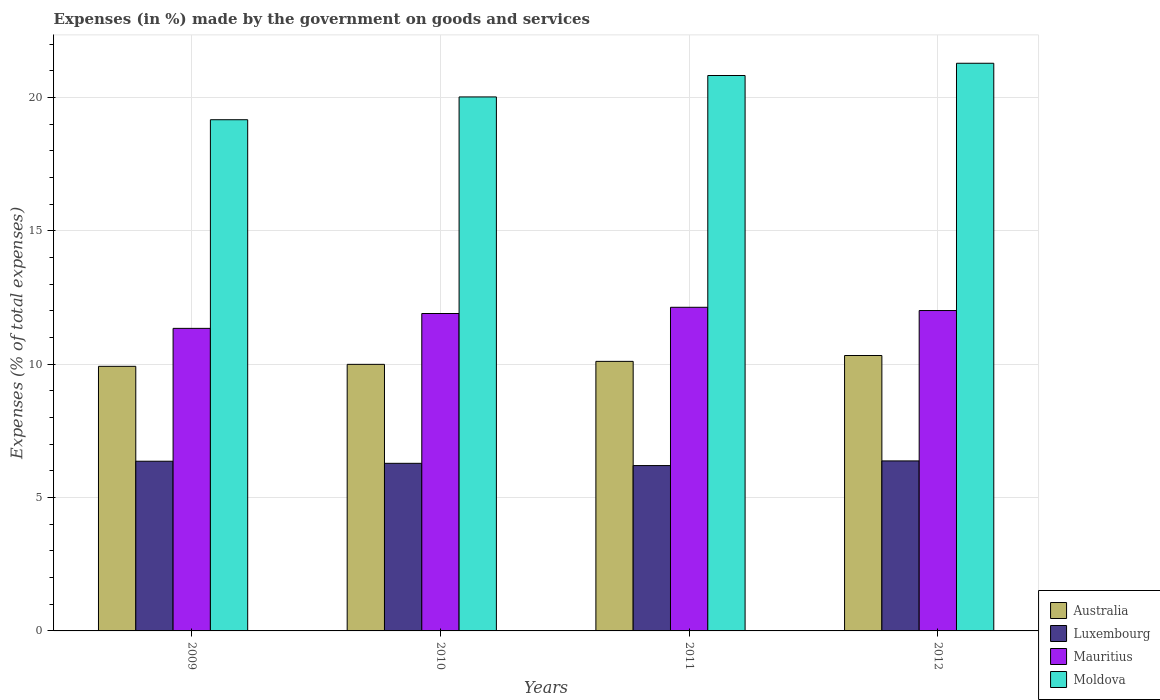How many different coloured bars are there?
Keep it short and to the point. 4. Are the number of bars on each tick of the X-axis equal?
Offer a very short reply. Yes. How many bars are there on the 3rd tick from the right?
Your answer should be compact. 4. What is the percentage of expenses made by the government on goods and services in Australia in 2009?
Your response must be concise. 9.92. Across all years, what is the maximum percentage of expenses made by the government on goods and services in Moldova?
Provide a short and direct response. 21.28. Across all years, what is the minimum percentage of expenses made by the government on goods and services in Australia?
Provide a succinct answer. 9.92. What is the total percentage of expenses made by the government on goods and services in Mauritius in the graph?
Give a very brief answer. 47.38. What is the difference between the percentage of expenses made by the government on goods and services in Australia in 2010 and that in 2011?
Offer a terse response. -0.11. What is the difference between the percentage of expenses made by the government on goods and services in Luxembourg in 2011 and the percentage of expenses made by the government on goods and services in Australia in 2012?
Offer a very short reply. -4.13. What is the average percentage of expenses made by the government on goods and services in Moldova per year?
Give a very brief answer. 20.32. In the year 2011, what is the difference between the percentage of expenses made by the government on goods and services in Moldova and percentage of expenses made by the government on goods and services in Luxembourg?
Ensure brevity in your answer.  14.62. What is the ratio of the percentage of expenses made by the government on goods and services in Mauritius in 2010 to that in 2012?
Offer a very short reply. 0.99. Is the percentage of expenses made by the government on goods and services in Moldova in 2010 less than that in 2011?
Your answer should be very brief. Yes. What is the difference between the highest and the second highest percentage of expenses made by the government on goods and services in Mauritius?
Provide a short and direct response. 0.12. What is the difference between the highest and the lowest percentage of expenses made by the government on goods and services in Moldova?
Ensure brevity in your answer.  2.12. In how many years, is the percentage of expenses made by the government on goods and services in Mauritius greater than the average percentage of expenses made by the government on goods and services in Mauritius taken over all years?
Ensure brevity in your answer.  3. Is the sum of the percentage of expenses made by the government on goods and services in Luxembourg in 2011 and 2012 greater than the maximum percentage of expenses made by the government on goods and services in Mauritius across all years?
Provide a succinct answer. Yes. Is it the case that in every year, the sum of the percentage of expenses made by the government on goods and services in Mauritius and percentage of expenses made by the government on goods and services in Moldova is greater than the sum of percentage of expenses made by the government on goods and services in Luxembourg and percentage of expenses made by the government on goods and services in Australia?
Keep it short and to the point. Yes. Is it the case that in every year, the sum of the percentage of expenses made by the government on goods and services in Mauritius and percentage of expenses made by the government on goods and services in Moldova is greater than the percentage of expenses made by the government on goods and services in Luxembourg?
Your response must be concise. Yes. How many bars are there?
Offer a terse response. 16. Are all the bars in the graph horizontal?
Ensure brevity in your answer.  No. How many years are there in the graph?
Provide a succinct answer. 4. What is the difference between two consecutive major ticks on the Y-axis?
Provide a succinct answer. 5. Where does the legend appear in the graph?
Make the answer very short. Bottom right. How many legend labels are there?
Provide a short and direct response. 4. How are the legend labels stacked?
Provide a short and direct response. Vertical. What is the title of the graph?
Offer a terse response. Expenses (in %) made by the government on goods and services. What is the label or title of the X-axis?
Keep it short and to the point. Years. What is the label or title of the Y-axis?
Offer a terse response. Expenses (% of total expenses). What is the Expenses (% of total expenses) of Australia in 2009?
Your answer should be very brief. 9.92. What is the Expenses (% of total expenses) of Luxembourg in 2009?
Provide a short and direct response. 6.36. What is the Expenses (% of total expenses) in Mauritius in 2009?
Your answer should be compact. 11.34. What is the Expenses (% of total expenses) in Moldova in 2009?
Give a very brief answer. 19.16. What is the Expenses (% of total expenses) of Australia in 2010?
Offer a very short reply. 9.99. What is the Expenses (% of total expenses) of Luxembourg in 2010?
Provide a short and direct response. 6.28. What is the Expenses (% of total expenses) of Mauritius in 2010?
Provide a succinct answer. 11.9. What is the Expenses (% of total expenses) in Moldova in 2010?
Your answer should be compact. 20.02. What is the Expenses (% of total expenses) of Australia in 2011?
Provide a short and direct response. 10.11. What is the Expenses (% of total expenses) in Luxembourg in 2011?
Your answer should be compact. 6.2. What is the Expenses (% of total expenses) in Mauritius in 2011?
Provide a short and direct response. 12.13. What is the Expenses (% of total expenses) of Moldova in 2011?
Keep it short and to the point. 20.82. What is the Expenses (% of total expenses) of Australia in 2012?
Offer a terse response. 10.32. What is the Expenses (% of total expenses) of Luxembourg in 2012?
Keep it short and to the point. 6.37. What is the Expenses (% of total expenses) in Mauritius in 2012?
Ensure brevity in your answer.  12.01. What is the Expenses (% of total expenses) in Moldova in 2012?
Make the answer very short. 21.28. Across all years, what is the maximum Expenses (% of total expenses) in Australia?
Your answer should be compact. 10.32. Across all years, what is the maximum Expenses (% of total expenses) in Luxembourg?
Offer a very short reply. 6.37. Across all years, what is the maximum Expenses (% of total expenses) of Mauritius?
Provide a short and direct response. 12.13. Across all years, what is the maximum Expenses (% of total expenses) in Moldova?
Provide a short and direct response. 21.28. Across all years, what is the minimum Expenses (% of total expenses) in Australia?
Offer a terse response. 9.92. Across all years, what is the minimum Expenses (% of total expenses) of Luxembourg?
Keep it short and to the point. 6.2. Across all years, what is the minimum Expenses (% of total expenses) in Mauritius?
Keep it short and to the point. 11.34. Across all years, what is the minimum Expenses (% of total expenses) of Moldova?
Give a very brief answer. 19.16. What is the total Expenses (% of total expenses) in Australia in the graph?
Offer a terse response. 40.34. What is the total Expenses (% of total expenses) of Luxembourg in the graph?
Offer a very short reply. 25.22. What is the total Expenses (% of total expenses) of Mauritius in the graph?
Your response must be concise. 47.38. What is the total Expenses (% of total expenses) of Moldova in the graph?
Offer a terse response. 81.28. What is the difference between the Expenses (% of total expenses) of Australia in 2009 and that in 2010?
Provide a short and direct response. -0.07. What is the difference between the Expenses (% of total expenses) in Luxembourg in 2009 and that in 2010?
Provide a short and direct response. 0.08. What is the difference between the Expenses (% of total expenses) in Mauritius in 2009 and that in 2010?
Your response must be concise. -0.56. What is the difference between the Expenses (% of total expenses) of Moldova in 2009 and that in 2010?
Your answer should be compact. -0.85. What is the difference between the Expenses (% of total expenses) of Australia in 2009 and that in 2011?
Provide a short and direct response. -0.19. What is the difference between the Expenses (% of total expenses) of Luxembourg in 2009 and that in 2011?
Offer a terse response. 0.16. What is the difference between the Expenses (% of total expenses) in Mauritius in 2009 and that in 2011?
Give a very brief answer. -0.79. What is the difference between the Expenses (% of total expenses) in Moldova in 2009 and that in 2011?
Provide a short and direct response. -1.66. What is the difference between the Expenses (% of total expenses) in Australia in 2009 and that in 2012?
Offer a very short reply. -0.41. What is the difference between the Expenses (% of total expenses) in Luxembourg in 2009 and that in 2012?
Your answer should be compact. -0.01. What is the difference between the Expenses (% of total expenses) in Mauritius in 2009 and that in 2012?
Provide a succinct answer. -0.67. What is the difference between the Expenses (% of total expenses) in Moldova in 2009 and that in 2012?
Give a very brief answer. -2.12. What is the difference between the Expenses (% of total expenses) of Australia in 2010 and that in 2011?
Ensure brevity in your answer.  -0.11. What is the difference between the Expenses (% of total expenses) of Luxembourg in 2010 and that in 2011?
Your answer should be very brief. 0.08. What is the difference between the Expenses (% of total expenses) of Mauritius in 2010 and that in 2011?
Provide a short and direct response. -0.23. What is the difference between the Expenses (% of total expenses) of Moldova in 2010 and that in 2011?
Make the answer very short. -0.8. What is the difference between the Expenses (% of total expenses) in Australia in 2010 and that in 2012?
Provide a short and direct response. -0.33. What is the difference between the Expenses (% of total expenses) in Luxembourg in 2010 and that in 2012?
Keep it short and to the point. -0.09. What is the difference between the Expenses (% of total expenses) in Mauritius in 2010 and that in 2012?
Your answer should be very brief. -0.11. What is the difference between the Expenses (% of total expenses) of Moldova in 2010 and that in 2012?
Provide a succinct answer. -1.26. What is the difference between the Expenses (% of total expenses) of Australia in 2011 and that in 2012?
Provide a succinct answer. -0.22. What is the difference between the Expenses (% of total expenses) of Luxembourg in 2011 and that in 2012?
Offer a terse response. -0.17. What is the difference between the Expenses (% of total expenses) in Mauritius in 2011 and that in 2012?
Your answer should be compact. 0.12. What is the difference between the Expenses (% of total expenses) in Moldova in 2011 and that in 2012?
Provide a short and direct response. -0.46. What is the difference between the Expenses (% of total expenses) in Australia in 2009 and the Expenses (% of total expenses) in Luxembourg in 2010?
Your answer should be compact. 3.64. What is the difference between the Expenses (% of total expenses) of Australia in 2009 and the Expenses (% of total expenses) of Mauritius in 2010?
Your answer should be compact. -1.98. What is the difference between the Expenses (% of total expenses) of Australia in 2009 and the Expenses (% of total expenses) of Moldova in 2010?
Your response must be concise. -10.1. What is the difference between the Expenses (% of total expenses) of Luxembourg in 2009 and the Expenses (% of total expenses) of Mauritius in 2010?
Your answer should be compact. -5.54. What is the difference between the Expenses (% of total expenses) in Luxembourg in 2009 and the Expenses (% of total expenses) in Moldova in 2010?
Your answer should be compact. -13.66. What is the difference between the Expenses (% of total expenses) in Mauritius in 2009 and the Expenses (% of total expenses) in Moldova in 2010?
Keep it short and to the point. -8.68. What is the difference between the Expenses (% of total expenses) in Australia in 2009 and the Expenses (% of total expenses) in Luxembourg in 2011?
Offer a terse response. 3.72. What is the difference between the Expenses (% of total expenses) in Australia in 2009 and the Expenses (% of total expenses) in Mauritius in 2011?
Offer a very short reply. -2.21. What is the difference between the Expenses (% of total expenses) of Australia in 2009 and the Expenses (% of total expenses) of Moldova in 2011?
Make the answer very short. -10.9. What is the difference between the Expenses (% of total expenses) in Luxembourg in 2009 and the Expenses (% of total expenses) in Mauritius in 2011?
Your response must be concise. -5.77. What is the difference between the Expenses (% of total expenses) of Luxembourg in 2009 and the Expenses (% of total expenses) of Moldova in 2011?
Ensure brevity in your answer.  -14.46. What is the difference between the Expenses (% of total expenses) in Mauritius in 2009 and the Expenses (% of total expenses) in Moldova in 2011?
Provide a short and direct response. -9.48. What is the difference between the Expenses (% of total expenses) of Australia in 2009 and the Expenses (% of total expenses) of Luxembourg in 2012?
Your answer should be very brief. 3.55. What is the difference between the Expenses (% of total expenses) of Australia in 2009 and the Expenses (% of total expenses) of Mauritius in 2012?
Your answer should be very brief. -2.09. What is the difference between the Expenses (% of total expenses) in Australia in 2009 and the Expenses (% of total expenses) in Moldova in 2012?
Ensure brevity in your answer.  -11.36. What is the difference between the Expenses (% of total expenses) in Luxembourg in 2009 and the Expenses (% of total expenses) in Mauritius in 2012?
Your response must be concise. -5.65. What is the difference between the Expenses (% of total expenses) of Luxembourg in 2009 and the Expenses (% of total expenses) of Moldova in 2012?
Your answer should be very brief. -14.92. What is the difference between the Expenses (% of total expenses) of Mauritius in 2009 and the Expenses (% of total expenses) of Moldova in 2012?
Ensure brevity in your answer.  -9.94. What is the difference between the Expenses (% of total expenses) of Australia in 2010 and the Expenses (% of total expenses) of Luxembourg in 2011?
Ensure brevity in your answer.  3.79. What is the difference between the Expenses (% of total expenses) in Australia in 2010 and the Expenses (% of total expenses) in Mauritius in 2011?
Ensure brevity in your answer.  -2.14. What is the difference between the Expenses (% of total expenses) of Australia in 2010 and the Expenses (% of total expenses) of Moldova in 2011?
Offer a very short reply. -10.83. What is the difference between the Expenses (% of total expenses) in Luxembourg in 2010 and the Expenses (% of total expenses) in Mauritius in 2011?
Your answer should be very brief. -5.85. What is the difference between the Expenses (% of total expenses) of Luxembourg in 2010 and the Expenses (% of total expenses) of Moldova in 2011?
Provide a short and direct response. -14.54. What is the difference between the Expenses (% of total expenses) of Mauritius in 2010 and the Expenses (% of total expenses) of Moldova in 2011?
Ensure brevity in your answer.  -8.92. What is the difference between the Expenses (% of total expenses) in Australia in 2010 and the Expenses (% of total expenses) in Luxembourg in 2012?
Your answer should be compact. 3.62. What is the difference between the Expenses (% of total expenses) of Australia in 2010 and the Expenses (% of total expenses) of Mauritius in 2012?
Offer a very short reply. -2.02. What is the difference between the Expenses (% of total expenses) of Australia in 2010 and the Expenses (% of total expenses) of Moldova in 2012?
Keep it short and to the point. -11.29. What is the difference between the Expenses (% of total expenses) in Luxembourg in 2010 and the Expenses (% of total expenses) in Mauritius in 2012?
Your answer should be very brief. -5.73. What is the difference between the Expenses (% of total expenses) in Luxembourg in 2010 and the Expenses (% of total expenses) in Moldova in 2012?
Ensure brevity in your answer.  -15. What is the difference between the Expenses (% of total expenses) of Mauritius in 2010 and the Expenses (% of total expenses) of Moldova in 2012?
Provide a succinct answer. -9.38. What is the difference between the Expenses (% of total expenses) of Australia in 2011 and the Expenses (% of total expenses) of Luxembourg in 2012?
Your response must be concise. 3.73. What is the difference between the Expenses (% of total expenses) in Australia in 2011 and the Expenses (% of total expenses) in Mauritius in 2012?
Give a very brief answer. -1.91. What is the difference between the Expenses (% of total expenses) of Australia in 2011 and the Expenses (% of total expenses) of Moldova in 2012?
Your answer should be very brief. -11.18. What is the difference between the Expenses (% of total expenses) in Luxembourg in 2011 and the Expenses (% of total expenses) in Mauritius in 2012?
Your response must be concise. -5.81. What is the difference between the Expenses (% of total expenses) of Luxembourg in 2011 and the Expenses (% of total expenses) of Moldova in 2012?
Provide a short and direct response. -15.08. What is the difference between the Expenses (% of total expenses) of Mauritius in 2011 and the Expenses (% of total expenses) of Moldova in 2012?
Provide a short and direct response. -9.15. What is the average Expenses (% of total expenses) in Australia per year?
Offer a very short reply. 10.09. What is the average Expenses (% of total expenses) of Luxembourg per year?
Offer a very short reply. 6.3. What is the average Expenses (% of total expenses) in Mauritius per year?
Make the answer very short. 11.85. What is the average Expenses (% of total expenses) in Moldova per year?
Offer a very short reply. 20.32. In the year 2009, what is the difference between the Expenses (% of total expenses) of Australia and Expenses (% of total expenses) of Luxembourg?
Your answer should be compact. 3.56. In the year 2009, what is the difference between the Expenses (% of total expenses) in Australia and Expenses (% of total expenses) in Mauritius?
Ensure brevity in your answer.  -1.42. In the year 2009, what is the difference between the Expenses (% of total expenses) of Australia and Expenses (% of total expenses) of Moldova?
Your answer should be very brief. -9.24. In the year 2009, what is the difference between the Expenses (% of total expenses) of Luxembourg and Expenses (% of total expenses) of Mauritius?
Provide a short and direct response. -4.98. In the year 2009, what is the difference between the Expenses (% of total expenses) in Luxembourg and Expenses (% of total expenses) in Moldova?
Your answer should be very brief. -12.8. In the year 2009, what is the difference between the Expenses (% of total expenses) in Mauritius and Expenses (% of total expenses) in Moldova?
Offer a terse response. -7.82. In the year 2010, what is the difference between the Expenses (% of total expenses) of Australia and Expenses (% of total expenses) of Luxembourg?
Make the answer very short. 3.71. In the year 2010, what is the difference between the Expenses (% of total expenses) in Australia and Expenses (% of total expenses) in Mauritius?
Keep it short and to the point. -1.91. In the year 2010, what is the difference between the Expenses (% of total expenses) in Australia and Expenses (% of total expenses) in Moldova?
Provide a short and direct response. -10.03. In the year 2010, what is the difference between the Expenses (% of total expenses) of Luxembourg and Expenses (% of total expenses) of Mauritius?
Your answer should be very brief. -5.62. In the year 2010, what is the difference between the Expenses (% of total expenses) in Luxembourg and Expenses (% of total expenses) in Moldova?
Give a very brief answer. -13.73. In the year 2010, what is the difference between the Expenses (% of total expenses) of Mauritius and Expenses (% of total expenses) of Moldova?
Provide a short and direct response. -8.12. In the year 2011, what is the difference between the Expenses (% of total expenses) of Australia and Expenses (% of total expenses) of Luxembourg?
Your answer should be compact. 3.91. In the year 2011, what is the difference between the Expenses (% of total expenses) of Australia and Expenses (% of total expenses) of Mauritius?
Make the answer very short. -2.03. In the year 2011, what is the difference between the Expenses (% of total expenses) in Australia and Expenses (% of total expenses) in Moldova?
Your answer should be very brief. -10.72. In the year 2011, what is the difference between the Expenses (% of total expenses) in Luxembourg and Expenses (% of total expenses) in Mauritius?
Provide a short and direct response. -5.93. In the year 2011, what is the difference between the Expenses (% of total expenses) in Luxembourg and Expenses (% of total expenses) in Moldova?
Your response must be concise. -14.62. In the year 2011, what is the difference between the Expenses (% of total expenses) of Mauritius and Expenses (% of total expenses) of Moldova?
Give a very brief answer. -8.69. In the year 2012, what is the difference between the Expenses (% of total expenses) in Australia and Expenses (% of total expenses) in Luxembourg?
Your response must be concise. 3.95. In the year 2012, what is the difference between the Expenses (% of total expenses) in Australia and Expenses (% of total expenses) in Mauritius?
Your answer should be very brief. -1.69. In the year 2012, what is the difference between the Expenses (% of total expenses) in Australia and Expenses (% of total expenses) in Moldova?
Provide a short and direct response. -10.96. In the year 2012, what is the difference between the Expenses (% of total expenses) in Luxembourg and Expenses (% of total expenses) in Mauritius?
Your answer should be compact. -5.64. In the year 2012, what is the difference between the Expenses (% of total expenses) in Luxembourg and Expenses (% of total expenses) in Moldova?
Provide a succinct answer. -14.91. In the year 2012, what is the difference between the Expenses (% of total expenses) in Mauritius and Expenses (% of total expenses) in Moldova?
Your answer should be compact. -9.27. What is the ratio of the Expenses (% of total expenses) in Luxembourg in 2009 to that in 2010?
Make the answer very short. 1.01. What is the ratio of the Expenses (% of total expenses) of Mauritius in 2009 to that in 2010?
Your response must be concise. 0.95. What is the ratio of the Expenses (% of total expenses) in Moldova in 2009 to that in 2010?
Give a very brief answer. 0.96. What is the ratio of the Expenses (% of total expenses) in Australia in 2009 to that in 2011?
Your answer should be very brief. 0.98. What is the ratio of the Expenses (% of total expenses) of Luxembourg in 2009 to that in 2011?
Keep it short and to the point. 1.03. What is the ratio of the Expenses (% of total expenses) of Mauritius in 2009 to that in 2011?
Provide a short and direct response. 0.93. What is the ratio of the Expenses (% of total expenses) in Moldova in 2009 to that in 2011?
Make the answer very short. 0.92. What is the ratio of the Expenses (% of total expenses) of Australia in 2009 to that in 2012?
Make the answer very short. 0.96. What is the ratio of the Expenses (% of total expenses) of Luxembourg in 2009 to that in 2012?
Your answer should be compact. 1. What is the ratio of the Expenses (% of total expenses) in Mauritius in 2009 to that in 2012?
Give a very brief answer. 0.94. What is the ratio of the Expenses (% of total expenses) of Moldova in 2009 to that in 2012?
Offer a terse response. 0.9. What is the ratio of the Expenses (% of total expenses) in Australia in 2010 to that in 2011?
Your response must be concise. 0.99. What is the ratio of the Expenses (% of total expenses) in Luxembourg in 2010 to that in 2011?
Make the answer very short. 1.01. What is the ratio of the Expenses (% of total expenses) of Mauritius in 2010 to that in 2011?
Your response must be concise. 0.98. What is the ratio of the Expenses (% of total expenses) of Moldova in 2010 to that in 2011?
Your answer should be compact. 0.96. What is the ratio of the Expenses (% of total expenses) of Australia in 2010 to that in 2012?
Provide a short and direct response. 0.97. What is the ratio of the Expenses (% of total expenses) of Luxembourg in 2010 to that in 2012?
Ensure brevity in your answer.  0.99. What is the ratio of the Expenses (% of total expenses) in Moldova in 2010 to that in 2012?
Offer a very short reply. 0.94. What is the ratio of the Expenses (% of total expenses) of Australia in 2011 to that in 2012?
Provide a short and direct response. 0.98. What is the ratio of the Expenses (% of total expenses) in Luxembourg in 2011 to that in 2012?
Provide a short and direct response. 0.97. What is the ratio of the Expenses (% of total expenses) of Mauritius in 2011 to that in 2012?
Offer a very short reply. 1.01. What is the ratio of the Expenses (% of total expenses) in Moldova in 2011 to that in 2012?
Keep it short and to the point. 0.98. What is the difference between the highest and the second highest Expenses (% of total expenses) in Australia?
Your answer should be very brief. 0.22. What is the difference between the highest and the second highest Expenses (% of total expenses) in Luxembourg?
Keep it short and to the point. 0.01. What is the difference between the highest and the second highest Expenses (% of total expenses) of Mauritius?
Your response must be concise. 0.12. What is the difference between the highest and the second highest Expenses (% of total expenses) in Moldova?
Offer a terse response. 0.46. What is the difference between the highest and the lowest Expenses (% of total expenses) of Australia?
Make the answer very short. 0.41. What is the difference between the highest and the lowest Expenses (% of total expenses) of Luxembourg?
Offer a terse response. 0.17. What is the difference between the highest and the lowest Expenses (% of total expenses) in Mauritius?
Offer a terse response. 0.79. What is the difference between the highest and the lowest Expenses (% of total expenses) of Moldova?
Ensure brevity in your answer.  2.12. 